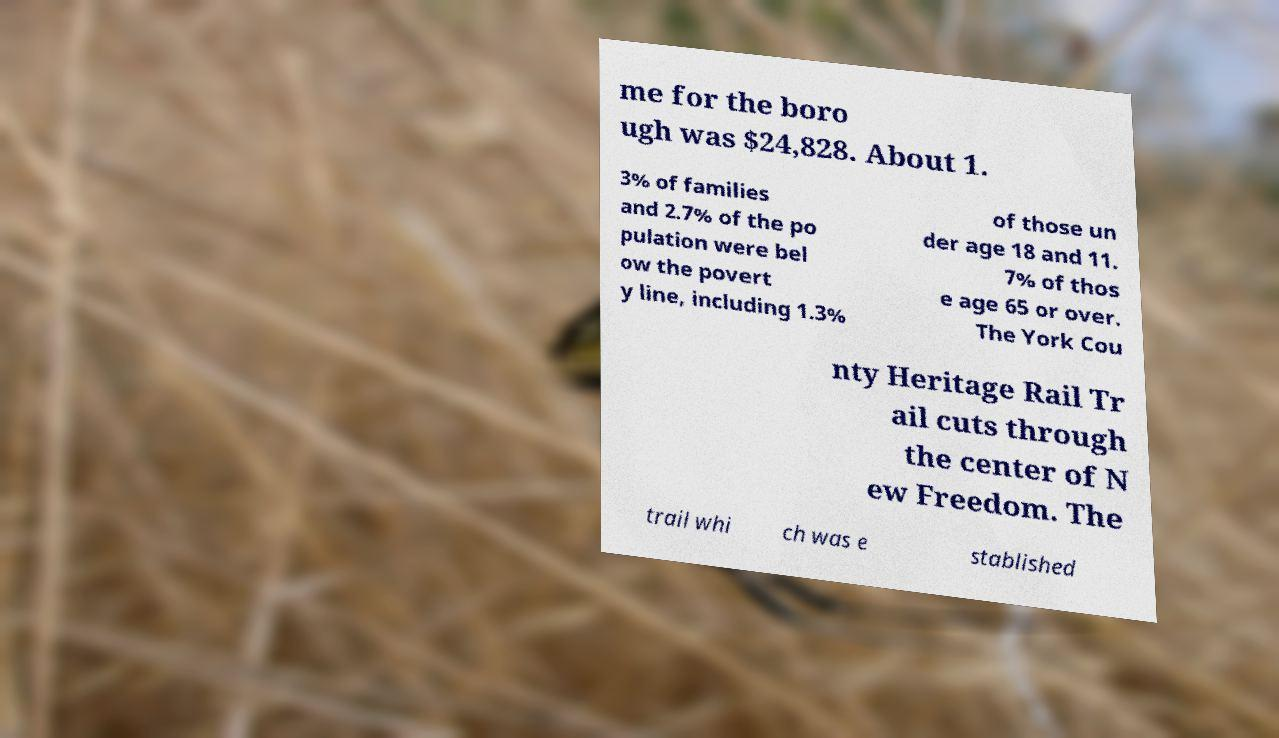Could you assist in decoding the text presented in this image and type it out clearly? me for the boro ugh was $24,828. About 1. 3% of families and 2.7% of the po pulation were bel ow the povert y line, including 1.3% of those un der age 18 and 11. 7% of thos e age 65 or over. The York Cou nty Heritage Rail Tr ail cuts through the center of N ew Freedom. The trail whi ch was e stablished 